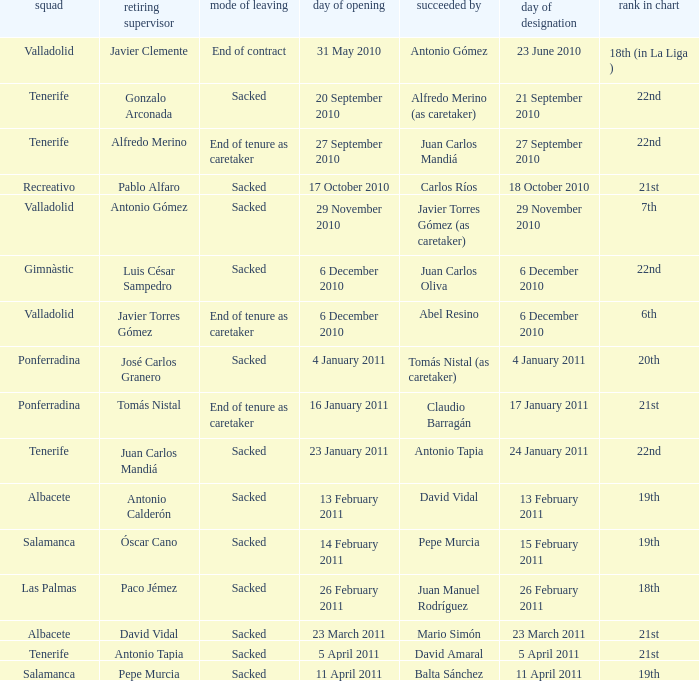How many teams had an outgoing manager of antonio gómez 1.0. 